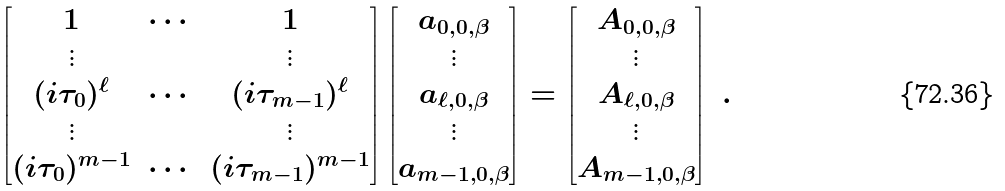<formula> <loc_0><loc_0><loc_500><loc_500>\begin{bmatrix} 1 & \cdots & 1 \\ \vdots & & \vdots \\ ( i \tau _ { 0 } ) ^ { \ell } & \cdots & ( i \tau _ { m - 1 } ) ^ { \ell } \\ \vdots & & \vdots \\ ( i \tau _ { 0 } ) ^ { m - 1 } & \cdots & ( i \tau _ { m - 1 } ) ^ { m - 1 } \end{bmatrix} \begin{bmatrix} a _ { 0 , 0 , \beta } \\ \vdots \\ a _ { { \ell } , 0 , \beta } \\ \vdots \\ a _ { m - 1 , 0 , \beta } \end{bmatrix} = \begin{bmatrix} A _ { 0 , 0 , \beta } \\ \vdots \\ A _ { { \ell } , 0 , \beta } \\ \vdots \\ A _ { m - 1 , 0 , \beta } \end{bmatrix} \ .</formula> 